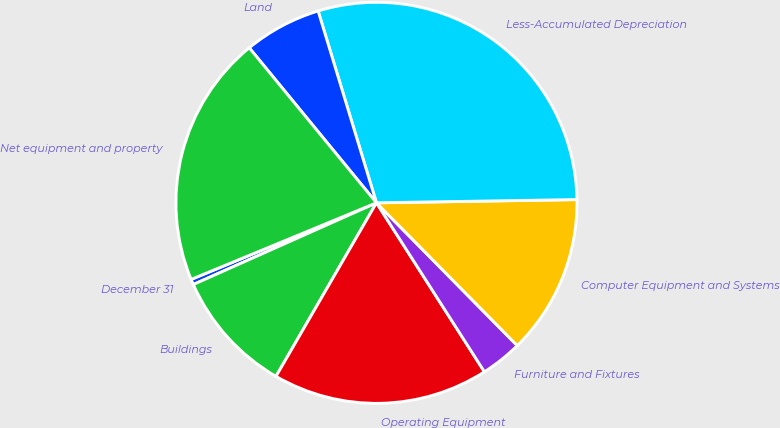<chart> <loc_0><loc_0><loc_500><loc_500><pie_chart><fcel>December 31<fcel>Buildings<fcel>Operating Equipment<fcel>Furniture and Fixtures<fcel>Computer Equipment and Systems<fcel>Less-Accumulated Depreciation<fcel>Land<fcel>Net equipment and property<nl><fcel>0.44%<fcel>9.97%<fcel>17.4%<fcel>3.34%<fcel>12.87%<fcel>29.44%<fcel>6.24%<fcel>20.3%<nl></chart> 